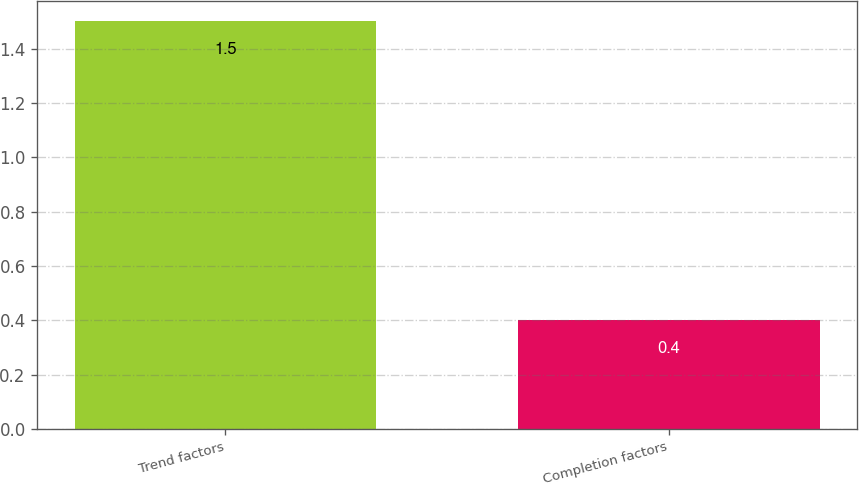Convert chart. <chart><loc_0><loc_0><loc_500><loc_500><bar_chart><fcel>Trend factors<fcel>Completion factors<nl><fcel>1.5<fcel>0.4<nl></chart> 